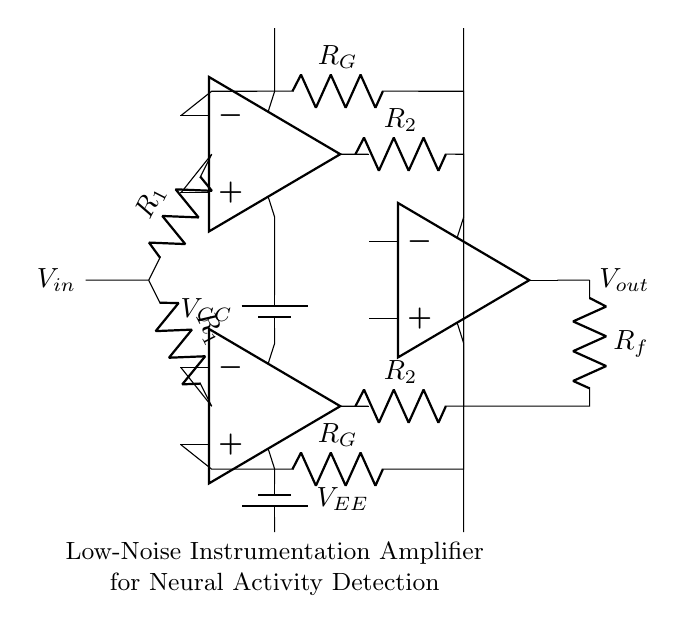What type of amplifier is represented in this circuit? The circuit is a low-noise instrumentation amplifier, which can be identified by its structure that includes multiple operational amplifiers designed for high input impedance and minimal noise.
Answer: low-noise instrumentation amplifier How many resistors are present in the circuit? The circuit contains four resistors: two labeled R1, two labeled R2, and one labeled R_G. By counting each resistor in the diagram, we find a total of four unique resistors.
Answer: four What is the purpose of the resistors R_G in this amplifier? The resistors labeled R_G are used for gain setting in this instrumentation amplifier. Specifically, they determine the overall gain of the amplifier, which is crucial for amplifying small signals.
Answer: gain setting What are the voltage supply labels in this circuit? The voltage supplies around the operational amplifiers are labeled as V_CC and V_EE, which represent the positive and negative supply voltages necessary for the operation of the op-amps.
Answer: V_CC and V_EE Which components are used for the output stage of the circuit? The output stage consists of an operational amplifier (labeled opamp3) and a feedback resistor (labeled R_f). The opamp combines the input signals and the feedback resistor helps set the output characteristics.
Answer: opamp3 and R_f How are the operational amplifiers connected in the input stage? The input stage contains two operational amplifiers connected in a differential configuration, where the inputs are linked through resistors, allowing them to amplify the voltage difference between two input signals.
Answer: differential configuration What is the function of the power supplies in this amplifier circuit? The power supplies provide the necessary operating voltages for the operational amplifiers. V_CC supplies the positive voltage required for the op-amps to operate, while V_EE supplies the negative voltage, essential for proper signal amplification in the circuit.
Answer: operating voltages 